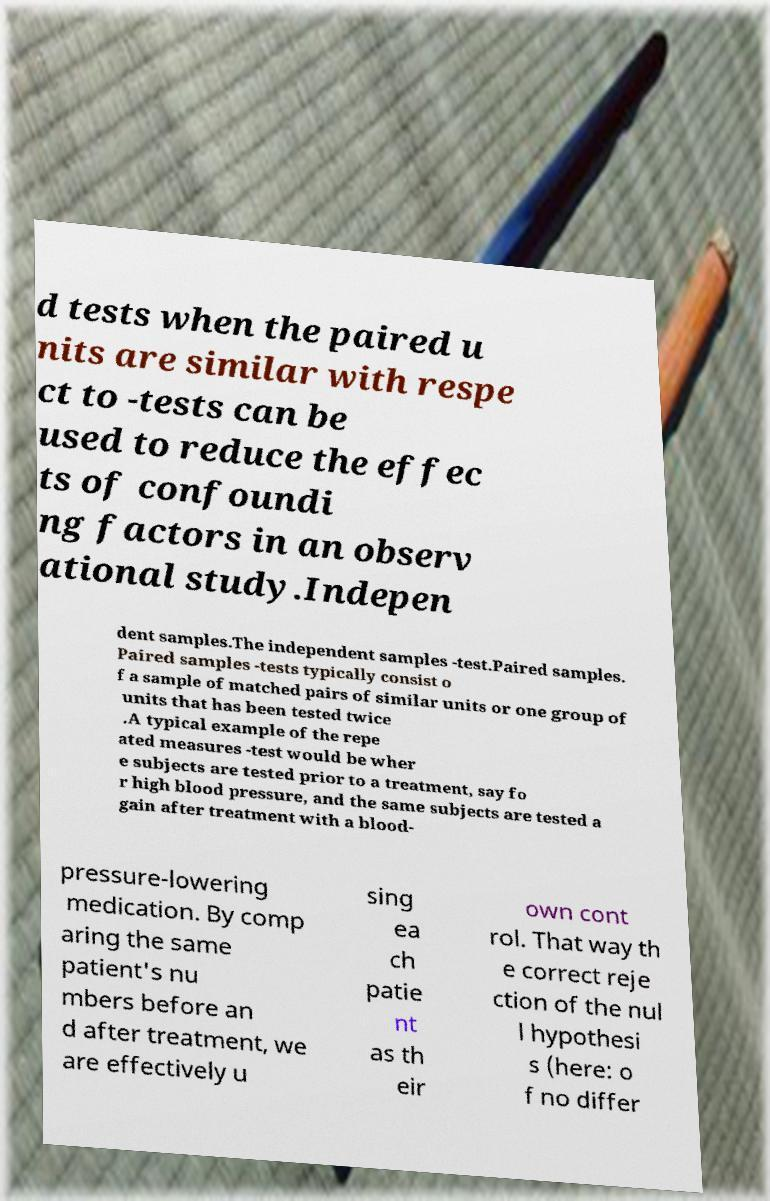Please read and relay the text visible in this image. What does it say? d tests when the paired u nits are similar with respe ct to -tests can be used to reduce the effec ts of confoundi ng factors in an observ ational study.Indepen dent samples.The independent samples -test.Paired samples. Paired samples -tests typically consist o f a sample of matched pairs of similar units or one group of units that has been tested twice .A typical example of the repe ated measures -test would be wher e subjects are tested prior to a treatment, say fo r high blood pressure, and the same subjects are tested a gain after treatment with a blood- pressure-lowering medication. By comp aring the same patient's nu mbers before an d after treatment, we are effectively u sing ea ch patie nt as th eir own cont rol. That way th e correct reje ction of the nul l hypothesi s (here: o f no differ 